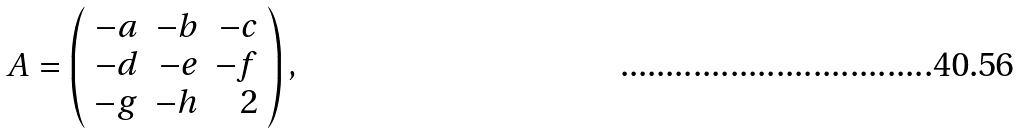Convert formula to latex. <formula><loc_0><loc_0><loc_500><loc_500>A = \left ( \begin{array} { r r r } - a & - b & - c \\ - d & - e & - f \\ - g & - h & 2 \end{array} \right ) ,</formula> 